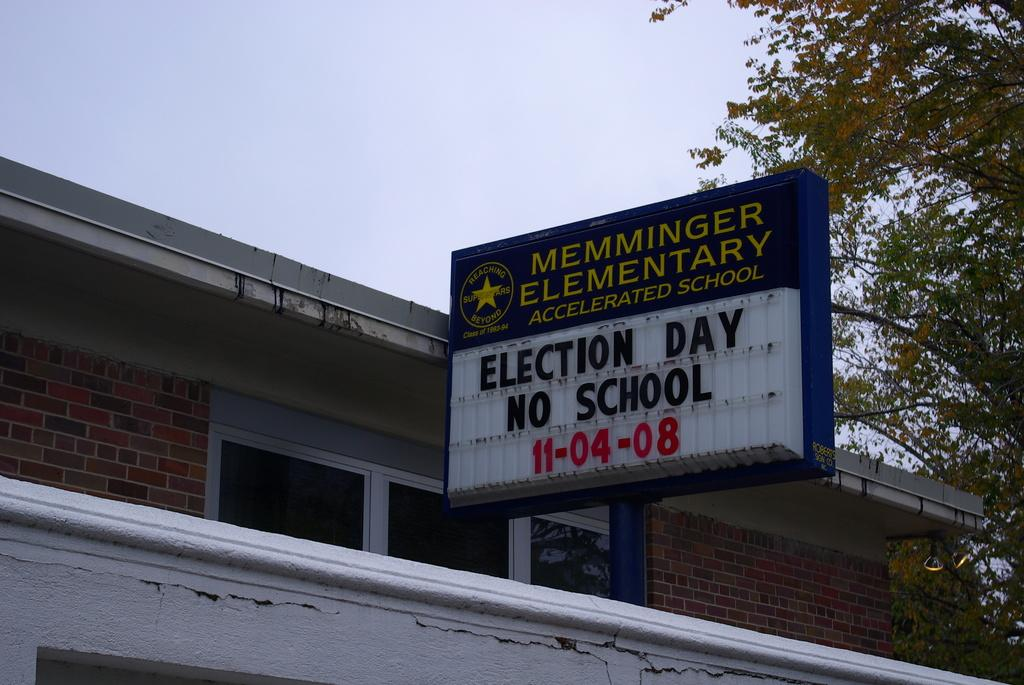What type of structure is visible in the image? There is a building in the image. Can you describe any specific features of the building? There is a window in the front of the building. What is located in front of the building? There is a blue-colored board in front of the building. What can be seen on the right side of the image? There is a tree on the right side of the image. What is visible at the top of the image? The sky is visible at the top of the image. How many owls are perched on the tree in the image? There are no owls present in the image; it only features a tree on the right side. 